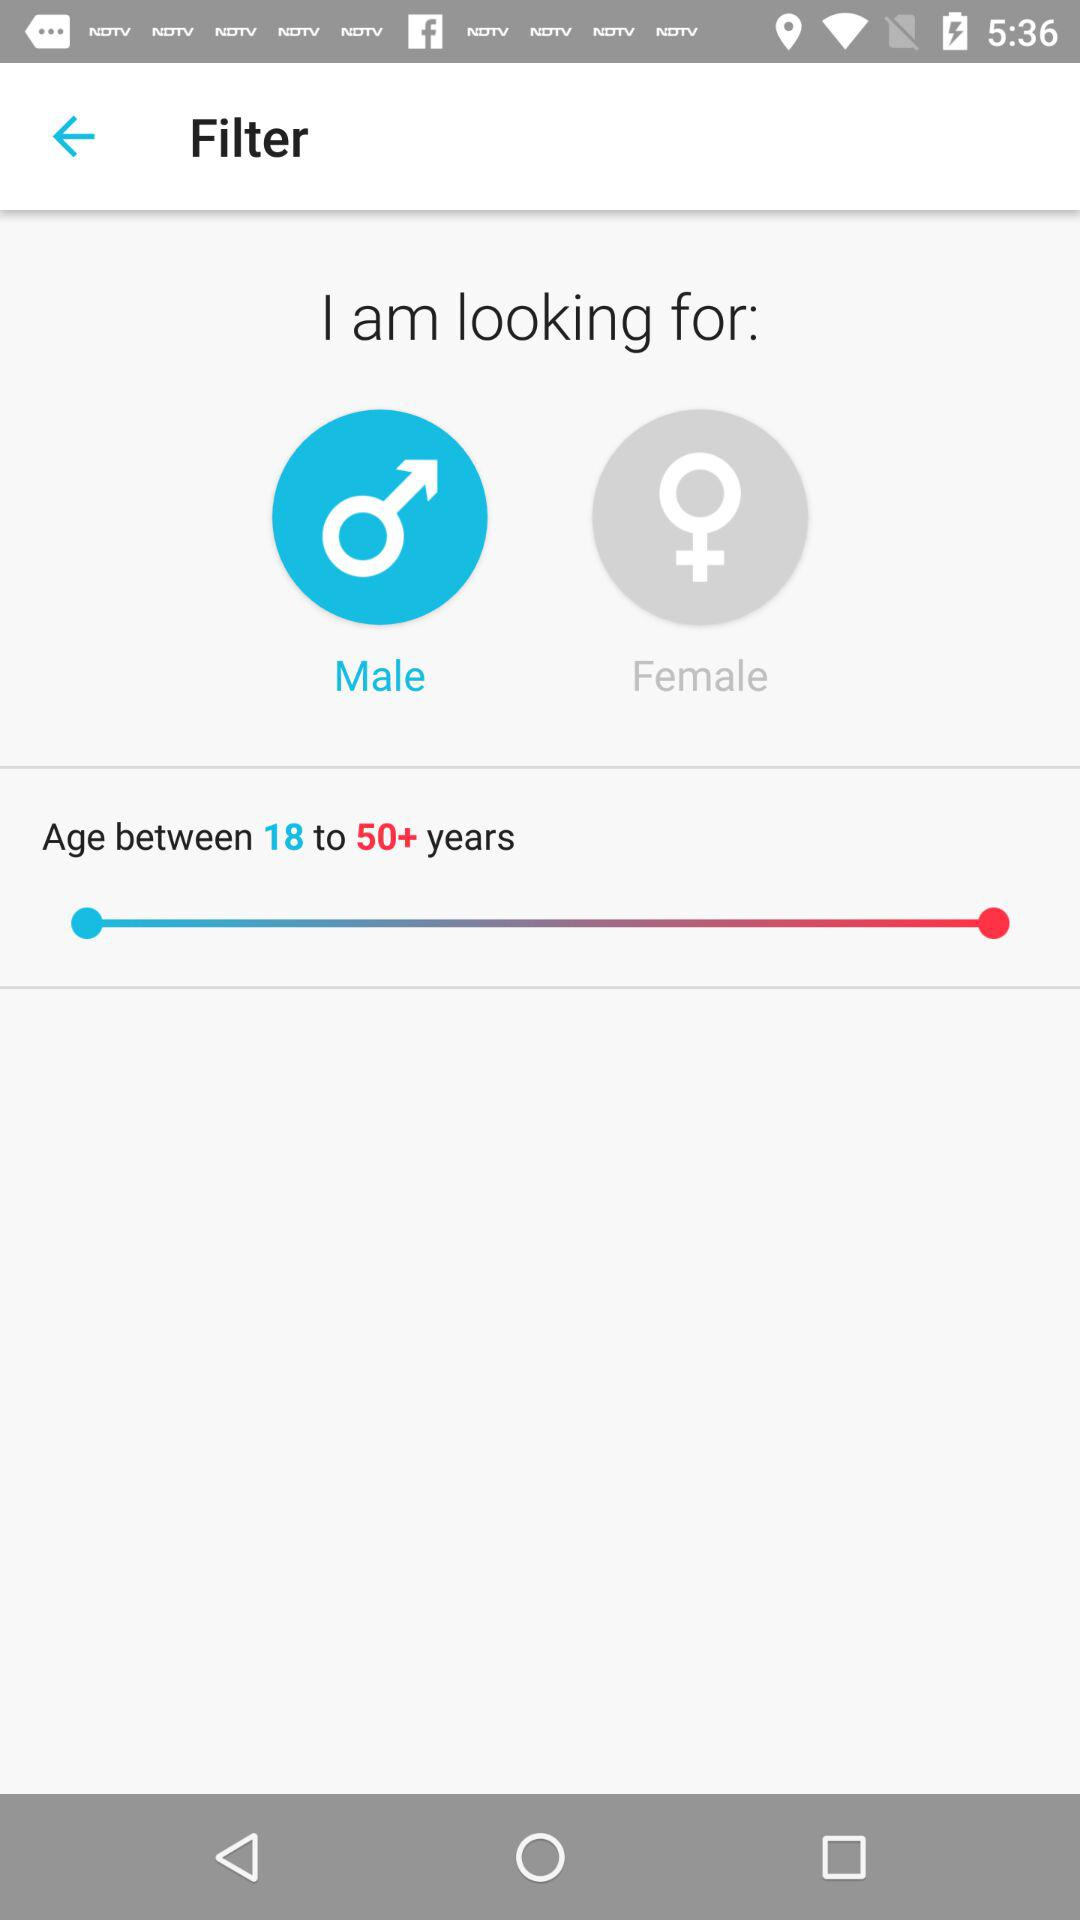How many options are available for gender?
Answer the question using a single word or phrase. 2 